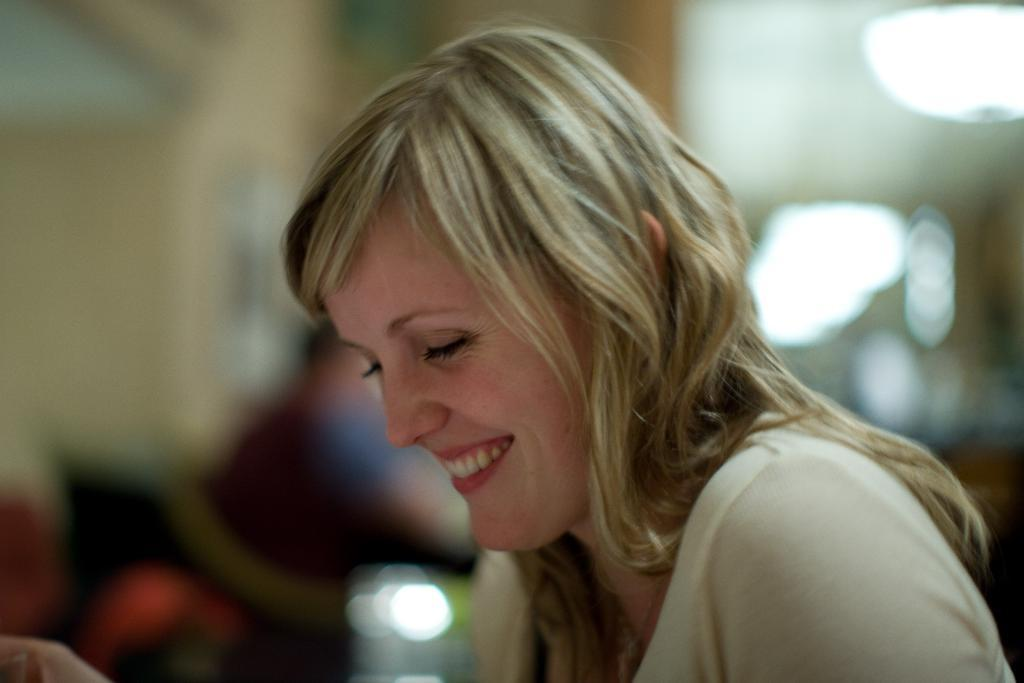Who is the main subject in the image? There is a lady in the image. Can you describe the background of the image? The background of the image is blurred. What type of bun is the lady holding in the image? There is no bun present in the image. What is the lady doing at her desk in the image? There is no desk present in the image, and the lady's actions are not described in the provided facts. 